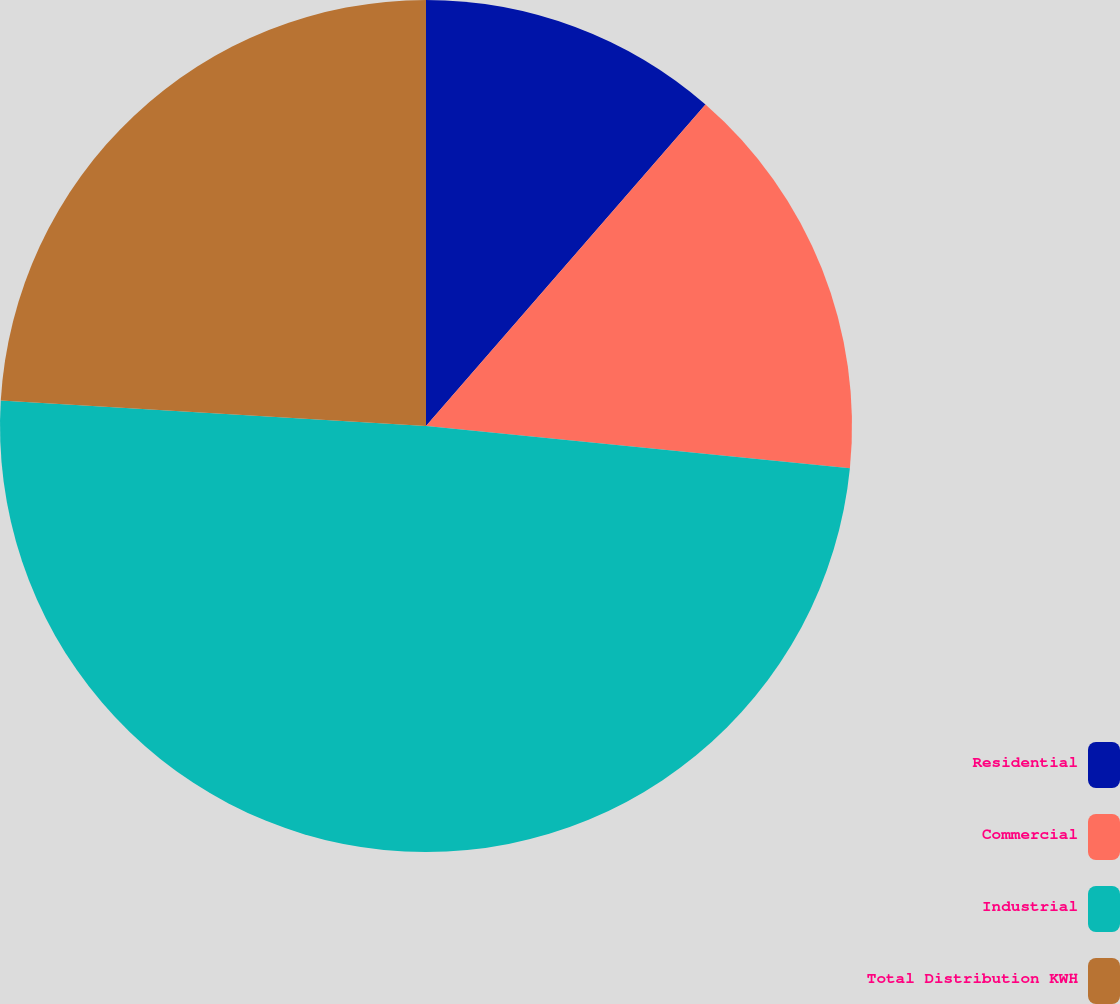Convert chart to OTSL. <chart><loc_0><loc_0><loc_500><loc_500><pie_chart><fcel>Residential<fcel>Commercial<fcel>Industrial<fcel>Total Distribution KWH<nl><fcel>11.39%<fcel>15.19%<fcel>49.37%<fcel>24.05%<nl></chart> 